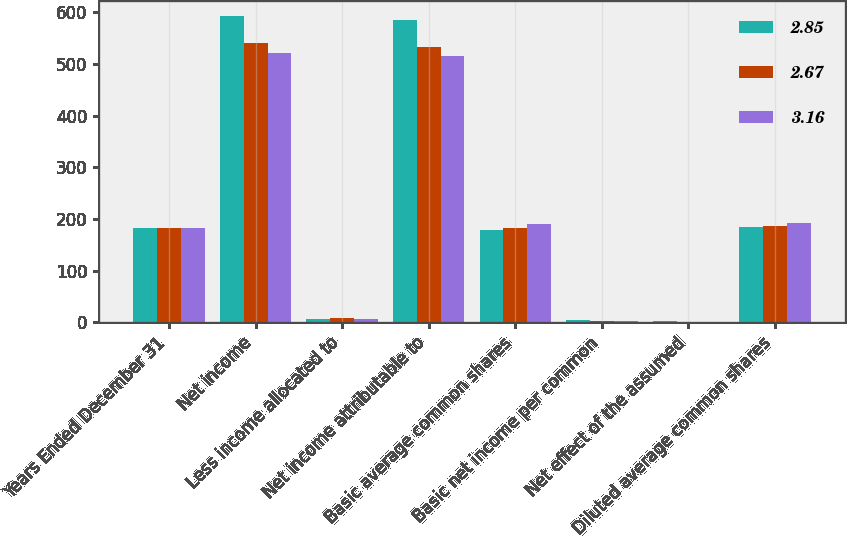Convert chart to OTSL. <chart><loc_0><loc_0><loc_500><loc_500><stacked_bar_chart><ecel><fcel>Years Ended December 31<fcel>Net income<fcel>Less income allocated to<fcel>Net income attributable to<fcel>Basic average common shares<fcel>Basic net income per common<fcel>Net effect of the assumed<fcel>Diluted average common shares<nl><fcel>2.85<fcel>183<fcel>593<fcel>7<fcel>586<fcel>179<fcel>3.28<fcel>2<fcel>185<nl><fcel>2.67<fcel>183<fcel>541<fcel>8<fcel>533<fcel>183<fcel>2.92<fcel>1<fcel>187<nl><fcel>3.16<fcel>183<fcel>521<fcel>6<fcel>515<fcel>191<fcel>2.68<fcel>1<fcel>192<nl></chart> 